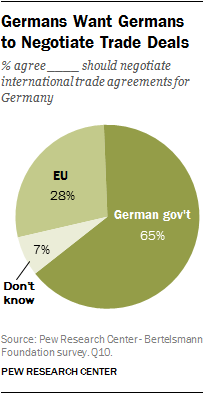Draw attention to some important aspects in this diagram. The product of the smallest segment and the second smallest segment is 196. Is the proportion of responses in the "Don't know" segment 7%? Yes, it is. 